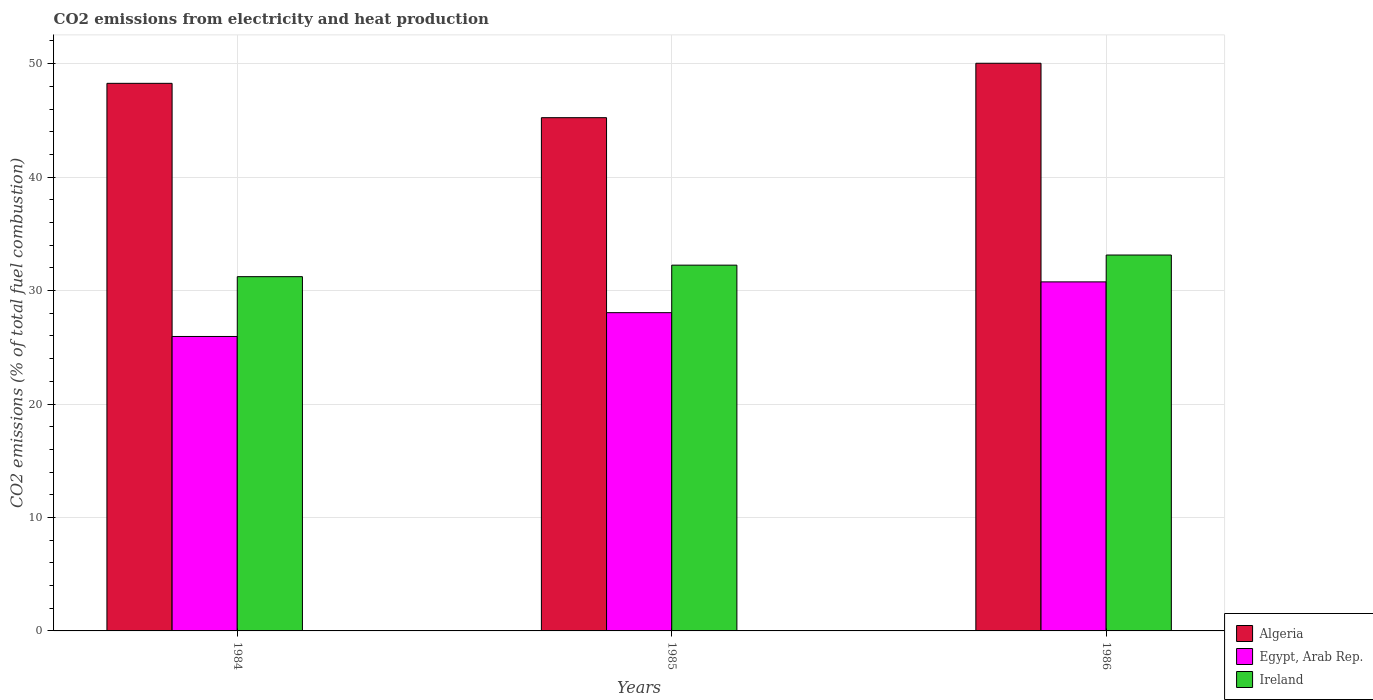How many different coloured bars are there?
Offer a very short reply. 3. Are the number of bars per tick equal to the number of legend labels?
Provide a short and direct response. Yes. How many bars are there on the 3rd tick from the left?
Give a very brief answer. 3. What is the label of the 3rd group of bars from the left?
Make the answer very short. 1986. What is the amount of CO2 emitted in Egypt, Arab Rep. in 1985?
Your answer should be compact. 28.05. Across all years, what is the maximum amount of CO2 emitted in Egypt, Arab Rep.?
Give a very brief answer. 30.76. Across all years, what is the minimum amount of CO2 emitted in Egypt, Arab Rep.?
Provide a succinct answer. 25.95. In which year was the amount of CO2 emitted in Ireland maximum?
Your answer should be very brief. 1986. What is the total amount of CO2 emitted in Algeria in the graph?
Provide a short and direct response. 143.53. What is the difference between the amount of CO2 emitted in Ireland in 1984 and that in 1985?
Give a very brief answer. -1.01. What is the difference between the amount of CO2 emitted in Algeria in 1986 and the amount of CO2 emitted in Ireland in 1985?
Give a very brief answer. 17.79. What is the average amount of CO2 emitted in Algeria per year?
Provide a short and direct response. 47.84. In the year 1984, what is the difference between the amount of CO2 emitted in Ireland and amount of CO2 emitted in Egypt, Arab Rep.?
Your answer should be compact. 5.27. What is the ratio of the amount of CO2 emitted in Algeria in 1985 to that in 1986?
Give a very brief answer. 0.9. What is the difference between the highest and the second highest amount of CO2 emitted in Egypt, Arab Rep.?
Provide a short and direct response. 2.71. What is the difference between the highest and the lowest amount of CO2 emitted in Algeria?
Provide a succinct answer. 4.8. Is the sum of the amount of CO2 emitted in Ireland in 1984 and 1985 greater than the maximum amount of CO2 emitted in Egypt, Arab Rep. across all years?
Offer a terse response. Yes. What does the 3rd bar from the left in 1985 represents?
Your answer should be very brief. Ireland. What does the 1st bar from the right in 1984 represents?
Offer a very short reply. Ireland. What is the difference between two consecutive major ticks on the Y-axis?
Your response must be concise. 10. Are the values on the major ticks of Y-axis written in scientific E-notation?
Offer a very short reply. No. Does the graph contain any zero values?
Make the answer very short. No. How many legend labels are there?
Keep it short and to the point. 3. How are the legend labels stacked?
Your response must be concise. Vertical. What is the title of the graph?
Provide a succinct answer. CO2 emissions from electricity and heat production. What is the label or title of the X-axis?
Your response must be concise. Years. What is the label or title of the Y-axis?
Offer a very short reply. CO2 emissions (% of total fuel combustion). What is the CO2 emissions (% of total fuel combustion) of Algeria in 1984?
Your answer should be very brief. 48.26. What is the CO2 emissions (% of total fuel combustion) in Egypt, Arab Rep. in 1984?
Your answer should be compact. 25.95. What is the CO2 emissions (% of total fuel combustion) of Ireland in 1984?
Make the answer very short. 31.22. What is the CO2 emissions (% of total fuel combustion) in Algeria in 1985?
Your answer should be very brief. 45.23. What is the CO2 emissions (% of total fuel combustion) in Egypt, Arab Rep. in 1985?
Your answer should be compact. 28.05. What is the CO2 emissions (% of total fuel combustion) of Ireland in 1985?
Provide a succinct answer. 32.24. What is the CO2 emissions (% of total fuel combustion) in Algeria in 1986?
Give a very brief answer. 50.03. What is the CO2 emissions (% of total fuel combustion) of Egypt, Arab Rep. in 1986?
Give a very brief answer. 30.76. What is the CO2 emissions (% of total fuel combustion) of Ireland in 1986?
Keep it short and to the point. 33.13. Across all years, what is the maximum CO2 emissions (% of total fuel combustion) in Algeria?
Ensure brevity in your answer.  50.03. Across all years, what is the maximum CO2 emissions (% of total fuel combustion) of Egypt, Arab Rep.?
Your answer should be compact. 30.76. Across all years, what is the maximum CO2 emissions (% of total fuel combustion) in Ireland?
Keep it short and to the point. 33.13. Across all years, what is the minimum CO2 emissions (% of total fuel combustion) in Algeria?
Ensure brevity in your answer.  45.23. Across all years, what is the minimum CO2 emissions (% of total fuel combustion) in Egypt, Arab Rep.?
Make the answer very short. 25.95. Across all years, what is the minimum CO2 emissions (% of total fuel combustion) in Ireland?
Make the answer very short. 31.22. What is the total CO2 emissions (% of total fuel combustion) in Algeria in the graph?
Keep it short and to the point. 143.53. What is the total CO2 emissions (% of total fuel combustion) in Egypt, Arab Rep. in the graph?
Provide a short and direct response. 84.76. What is the total CO2 emissions (% of total fuel combustion) in Ireland in the graph?
Your response must be concise. 96.59. What is the difference between the CO2 emissions (% of total fuel combustion) of Algeria in 1984 and that in 1985?
Your answer should be very brief. 3.03. What is the difference between the CO2 emissions (% of total fuel combustion) of Egypt, Arab Rep. in 1984 and that in 1985?
Your answer should be compact. -2.1. What is the difference between the CO2 emissions (% of total fuel combustion) of Ireland in 1984 and that in 1985?
Give a very brief answer. -1.01. What is the difference between the CO2 emissions (% of total fuel combustion) of Algeria in 1984 and that in 1986?
Keep it short and to the point. -1.77. What is the difference between the CO2 emissions (% of total fuel combustion) of Egypt, Arab Rep. in 1984 and that in 1986?
Your answer should be very brief. -4.81. What is the difference between the CO2 emissions (% of total fuel combustion) in Ireland in 1984 and that in 1986?
Keep it short and to the point. -1.91. What is the difference between the CO2 emissions (% of total fuel combustion) of Algeria in 1985 and that in 1986?
Give a very brief answer. -4.8. What is the difference between the CO2 emissions (% of total fuel combustion) in Egypt, Arab Rep. in 1985 and that in 1986?
Your answer should be very brief. -2.71. What is the difference between the CO2 emissions (% of total fuel combustion) of Ireland in 1985 and that in 1986?
Provide a succinct answer. -0.89. What is the difference between the CO2 emissions (% of total fuel combustion) in Algeria in 1984 and the CO2 emissions (% of total fuel combustion) in Egypt, Arab Rep. in 1985?
Give a very brief answer. 20.21. What is the difference between the CO2 emissions (% of total fuel combustion) of Algeria in 1984 and the CO2 emissions (% of total fuel combustion) of Ireland in 1985?
Your answer should be compact. 16.03. What is the difference between the CO2 emissions (% of total fuel combustion) of Egypt, Arab Rep. in 1984 and the CO2 emissions (% of total fuel combustion) of Ireland in 1985?
Ensure brevity in your answer.  -6.29. What is the difference between the CO2 emissions (% of total fuel combustion) of Algeria in 1984 and the CO2 emissions (% of total fuel combustion) of Egypt, Arab Rep. in 1986?
Your response must be concise. 17.5. What is the difference between the CO2 emissions (% of total fuel combustion) in Algeria in 1984 and the CO2 emissions (% of total fuel combustion) in Ireland in 1986?
Your answer should be very brief. 15.13. What is the difference between the CO2 emissions (% of total fuel combustion) of Egypt, Arab Rep. in 1984 and the CO2 emissions (% of total fuel combustion) of Ireland in 1986?
Offer a very short reply. -7.18. What is the difference between the CO2 emissions (% of total fuel combustion) of Algeria in 1985 and the CO2 emissions (% of total fuel combustion) of Egypt, Arab Rep. in 1986?
Give a very brief answer. 14.47. What is the difference between the CO2 emissions (% of total fuel combustion) in Algeria in 1985 and the CO2 emissions (% of total fuel combustion) in Ireland in 1986?
Make the answer very short. 12.1. What is the difference between the CO2 emissions (% of total fuel combustion) in Egypt, Arab Rep. in 1985 and the CO2 emissions (% of total fuel combustion) in Ireland in 1986?
Provide a short and direct response. -5.08. What is the average CO2 emissions (% of total fuel combustion) of Algeria per year?
Give a very brief answer. 47.84. What is the average CO2 emissions (% of total fuel combustion) of Egypt, Arab Rep. per year?
Offer a very short reply. 28.25. What is the average CO2 emissions (% of total fuel combustion) in Ireland per year?
Provide a short and direct response. 32.2. In the year 1984, what is the difference between the CO2 emissions (% of total fuel combustion) of Algeria and CO2 emissions (% of total fuel combustion) of Egypt, Arab Rep.?
Offer a terse response. 22.31. In the year 1984, what is the difference between the CO2 emissions (% of total fuel combustion) of Algeria and CO2 emissions (% of total fuel combustion) of Ireland?
Make the answer very short. 17.04. In the year 1984, what is the difference between the CO2 emissions (% of total fuel combustion) in Egypt, Arab Rep. and CO2 emissions (% of total fuel combustion) in Ireland?
Provide a short and direct response. -5.27. In the year 1985, what is the difference between the CO2 emissions (% of total fuel combustion) of Algeria and CO2 emissions (% of total fuel combustion) of Egypt, Arab Rep.?
Your response must be concise. 17.18. In the year 1985, what is the difference between the CO2 emissions (% of total fuel combustion) in Algeria and CO2 emissions (% of total fuel combustion) in Ireland?
Give a very brief answer. 13. In the year 1985, what is the difference between the CO2 emissions (% of total fuel combustion) of Egypt, Arab Rep. and CO2 emissions (% of total fuel combustion) of Ireland?
Provide a succinct answer. -4.19. In the year 1986, what is the difference between the CO2 emissions (% of total fuel combustion) of Algeria and CO2 emissions (% of total fuel combustion) of Egypt, Arab Rep.?
Your answer should be compact. 19.27. In the year 1986, what is the difference between the CO2 emissions (% of total fuel combustion) of Algeria and CO2 emissions (% of total fuel combustion) of Ireland?
Keep it short and to the point. 16.9. In the year 1986, what is the difference between the CO2 emissions (% of total fuel combustion) in Egypt, Arab Rep. and CO2 emissions (% of total fuel combustion) in Ireland?
Offer a terse response. -2.37. What is the ratio of the CO2 emissions (% of total fuel combustion) of Algeria in 1984 to that in 1985?
Provide a succinct answer. 1.07. What is the ratio of the CO2 emissions (% of total fuel combustion) of Egypt, Arab Rep. in 1984 to that in 1985?
Your answer should be compact. 0.93. What is the ratio of the CO2 emissions (% of total fuel combustion) of Ireland in 1984 to that in 1985?
Ensure brevity in your answer.  0.97. What is the ratio of the CO2 emissions (% of total fuel combustion) in Algeria in 1984 to that in 1986?
Your response must be concise. 0.96. What is the ratio of the CO2 emissions (% of total fuel combustion) in Egypt, Arab Rep. in 1984 to that in 1986?
Your response must be concise. 0.84. What is the ratio of the CO2 emissions (% of total fuel combustion) in Ireland in 1984 to that in 1986?
Give a very brief answer. 0.94. What is the ratio of the CO2 emissions (% of total fuel combustion) of Algeria in 1985 to that in 1986?
Offer a terse response. 0.9. What is the ratio of the CO2 emissions (% of total fuel combustion) in Egypt, Arab Rep. in 1985 to that in 1986?
Your answer should be compact. 0.91. What is the ratio of the CO2 emissions (% of total fuel combustion) in Ireland in 1985 to that in 1986?
Make the answer very short. 0.97. What is the difference between the highest and the second highest CO2 emissions (% of total fuel combustion) in Algeria?
Your response must be concise. 1.77. What is the difference between the highest and the second highest CO2 emissions (% of total fuel combustion) of Egypt, Arab Rep.?
Offer a terse response. 2.71. What is the difference between the highest and the second highest CO2 emissions (% of total fuel combustion) of Ireland?
Offer a terse response. 0.89. What is the difference between the highest and the lowest CO2 emissions (% of total fuel combustion) in Algeria?
Your answer should be compact. 4.8. What is the difference between the highest and the lowest CO2 emissions (% of total fuel combustion) in Egypt, Arab Rep.?
Your answer should be very brief. 4.81. What is the difference between the highest and the lowest CO2 emissions (% of total fuel combustion) in Ireland?
Your answer should be compact. 1.91. 